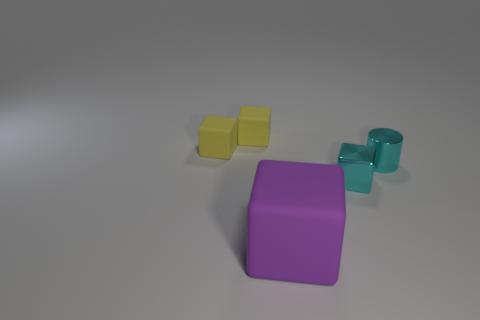How many cyan metallic objects are in front of the small block on the right side of the large purple rubber thing?
Keep it short and to the point. 0. How many objects are things left of the large matte cube or cyan cubes?
Keep it short and to the point. 3. Are there any small metal objects of the same shape as the purple rubber object?
Provide a short and direct response. Yes. There is a tiny thing on the right side of the small block that is to the right of the big purple rubber cube; what is its shape?
Ensure brevity in your answer.  Cylinder. What number of cylinders are either small metallic objects or big rubber things?
Give a very brief answer. 1. There is a small block that is the same color as the metal cylinder; what material is it?
Your response must be concise. Metal. Does the thing that is in front of the cyan cube have the same shape as the shiny object that is to the left of the small cylinder?
Your answer should be compact. Yes. What is the color of the tiny object that is on the right side of the big matte thing and left of the small cyan shiny cylinder?
Your answer should be very brief. Cyan. Does the shiny cylinder have the same color as the tiny cube on the right side of the purple block?
Ensure brevity in your answer.  Yes. What size is the object that is in front of the small cyan cylinder and on the left side of the tiny metallic cube?
Offer a terse response. Large. 